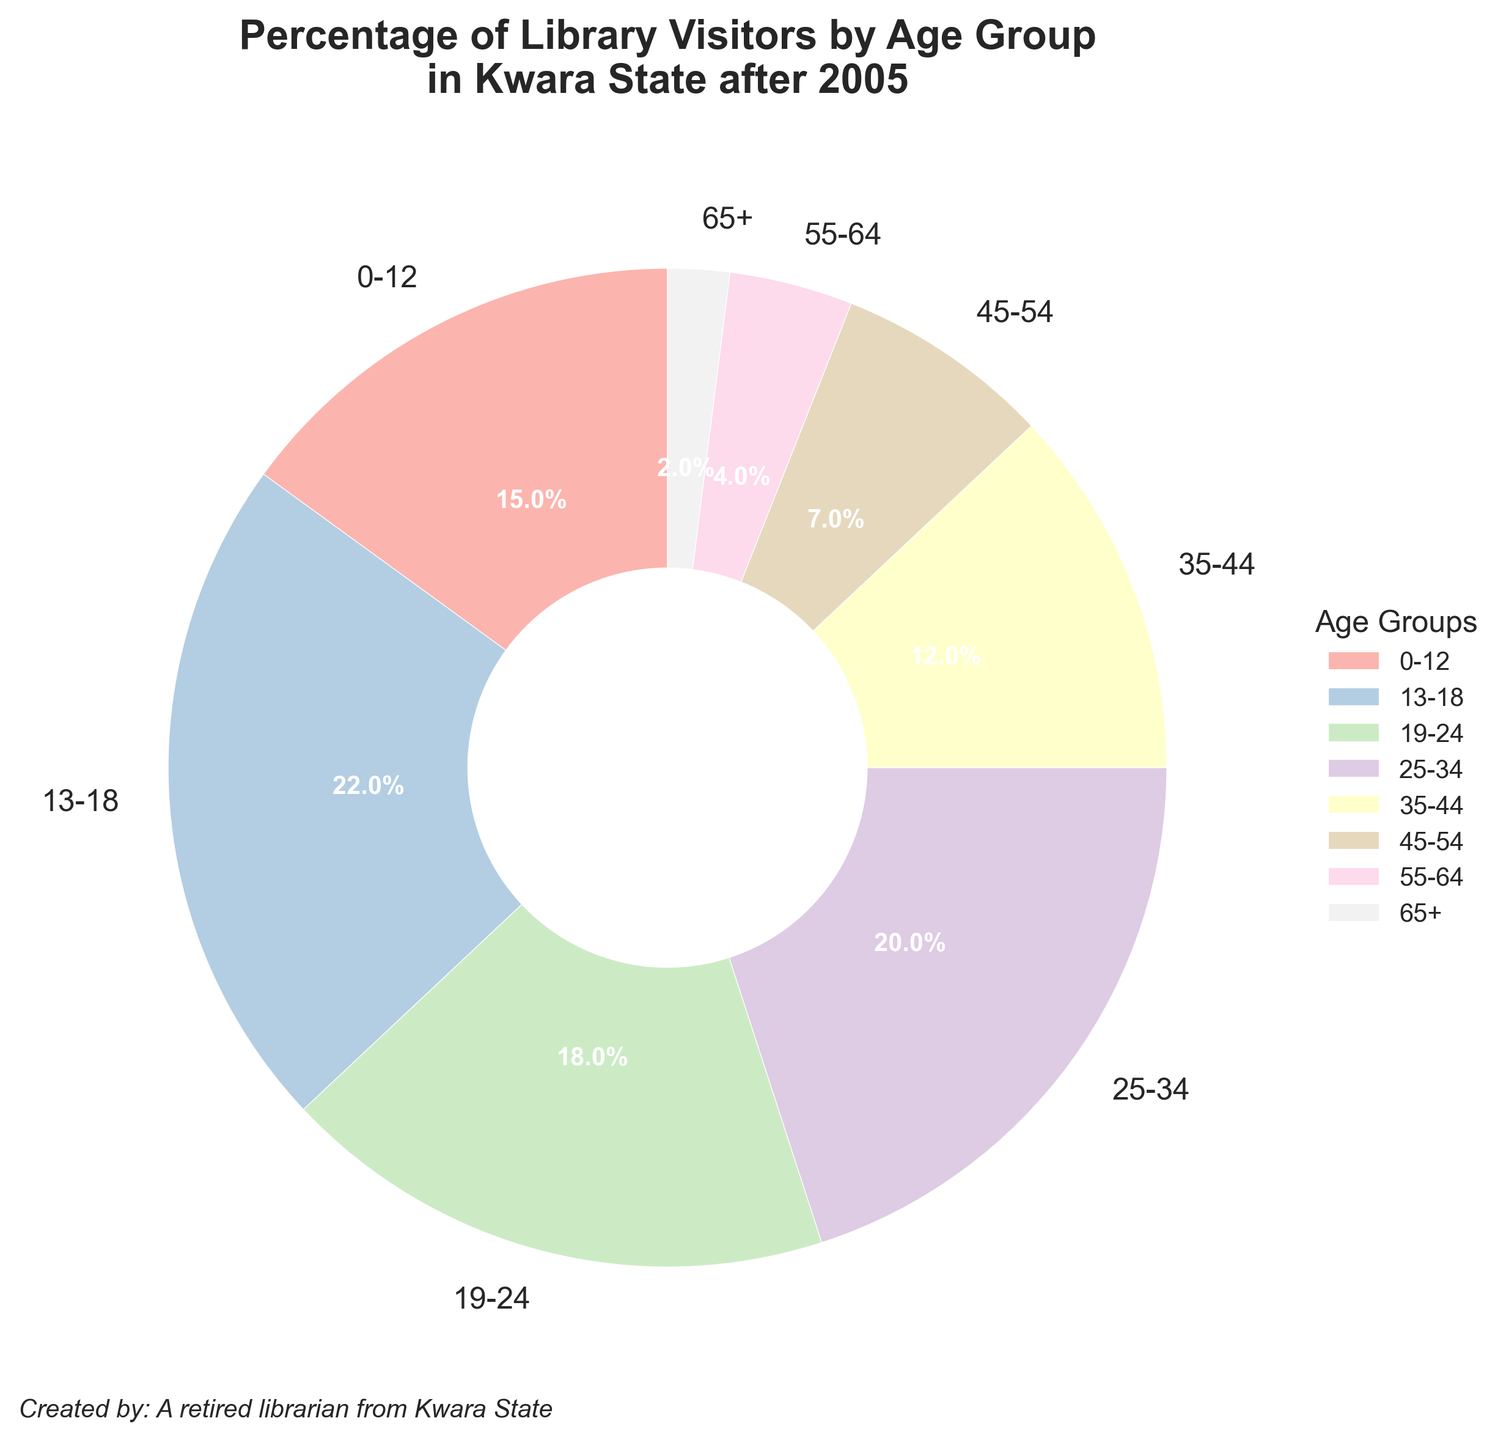What is the percentage of library visitors aged 0-12? The figure shows a segment labeled "0-12" with a percentage value on it, representing the proportion of library visitors in this age group.
Answer: 15% Which age group has the highest percentage of visitors? By inspecting the pie chart, the largest segment corresponds to the age group labeled with the highest percentage value.
Answer: 13-18 What is the combined percentage of library visitors aged 0-12 and 35-44? To find the combined percentage, sum the individual percentages of the two age groups: 15% and 12%. This involves straightforward addition.
Answer: 27% How does the percentage of visitors aged 55-64 compare to those aged 25-34? Look at both age groups' percentages on the pie chart. The percentage for 55-64 is 4%, and for 25-34 it is 20%.
Answer: 55-64 is lower than 25-34 What is the percentage difference between visitors aged 19-24 and 45-54? Subtract the percentage of the 45-54 age group (7%) from the percentage of the 19-24 age group (18%) to find the difference.
Answer: 11% Which age group has the smallest percentage of library visitors? Identify the smallest segment in the pie chart, which corresponds to the age group with the smallest percentage.
Answer: 65+ Is the percentage of visitors aged 25-34 more than twice the percentage of those aged 55-64? Compare the percentage of 25-34 (20%) to twice the percentage of 55-64 (2 x 4% = 8%). Since 20% > 8%, the answer is yes.
Answer: Yes What is the sum of the percentages of visitors aged 45-54, 55-64, and 65+? Add the percentages of these three age groups: 7%, 4%, and 2%. The sum is calculated as 7 + 4 + 2.
Answer: 13% Which age group segments are visually similar in size? By observing the pie chart, identify segments with similar areas or arc lengths representing close percentage values.
Answer: 19-24 and 25-34 What percentage of library visitors are aged below 18? Add the percentages of age groups 0-12 and 13-18: 15% and 22%. The total percentage is found by summing these values.
Answer: 37% 